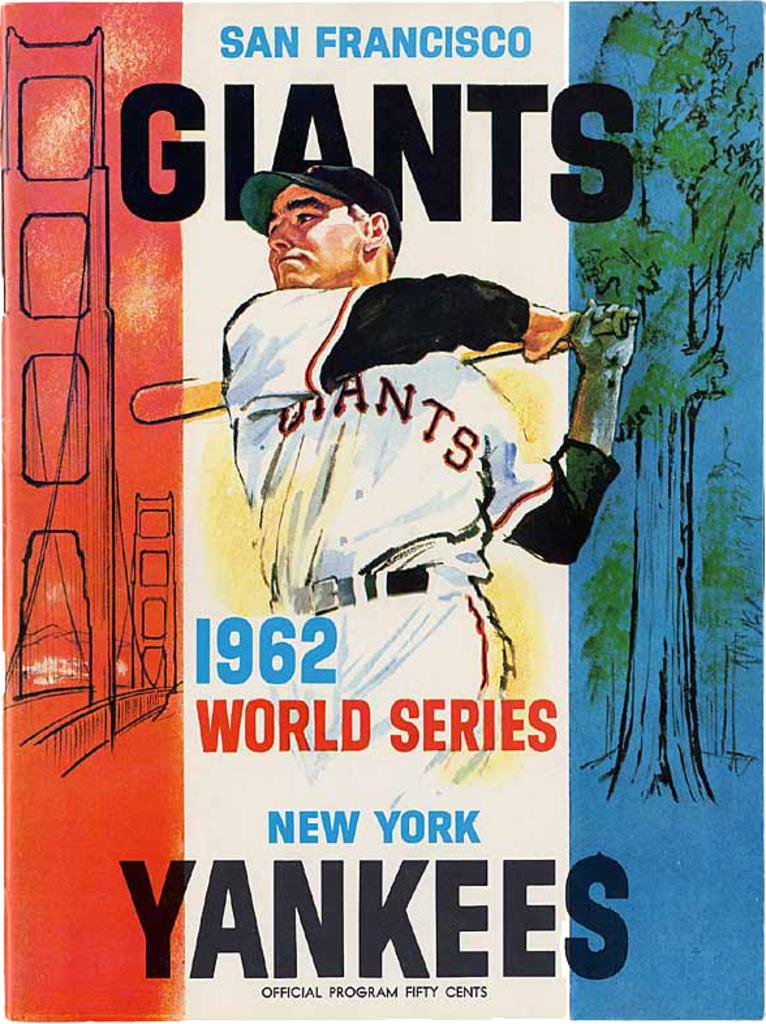Provide a one-sentence caption for the provided image. A program for a Giants and Yankees game from the 1962 world series. 